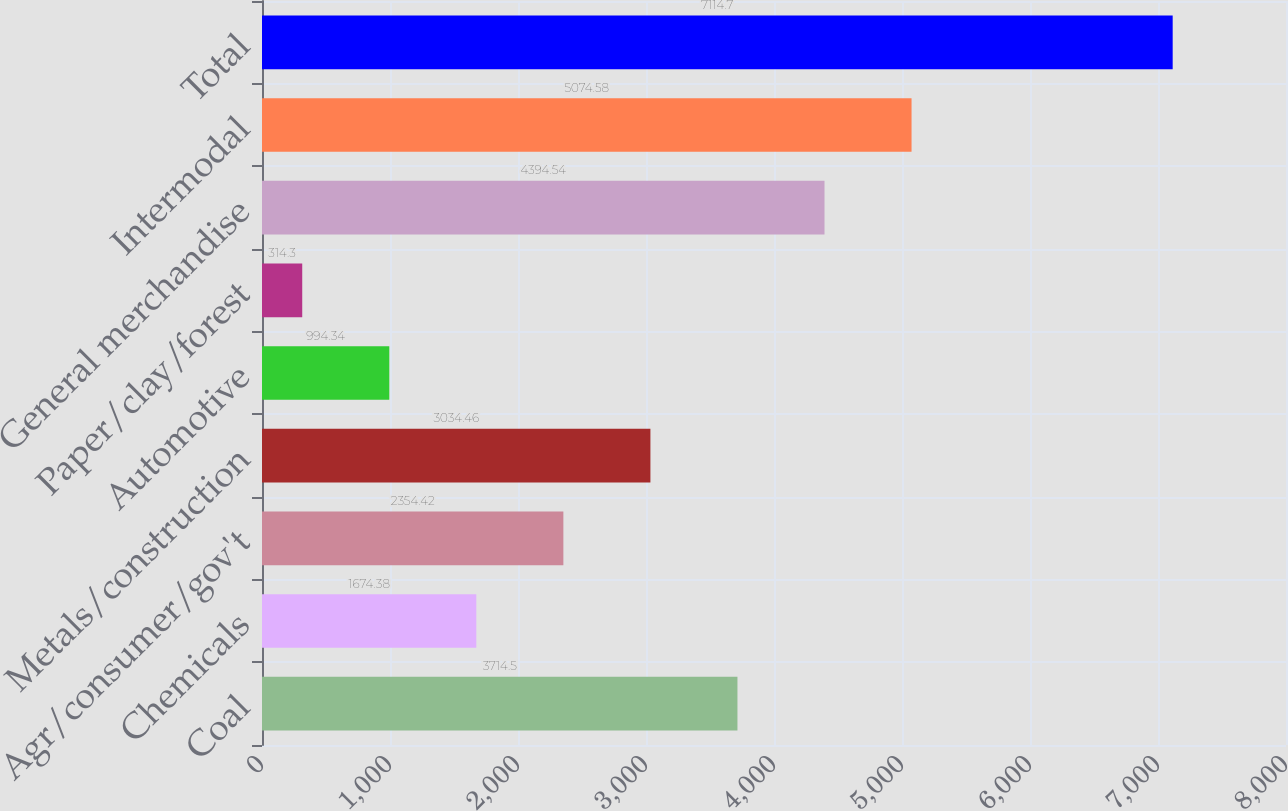Convert chart to OTSL. <chart><loc_0><loc_0><loc_500><loc_500><bar_chart><fcel>Coal<fcel>Chemicals<fcel>Agr/consumer/gov't<fcel>Metals/construction<fcel>Automotive<fcel>Paper/clay/forest<fcel>General merchandise<fcel>Intermodal<fcel>Total<nl><fcel>3714.5<fcel>1674.38<fcel>2354.42<fcel>3034.46<fcel>994.34<fcel>314.3<fcel>4394.54<fcel>5074.58<fcel>7114.7<nl></chart> 